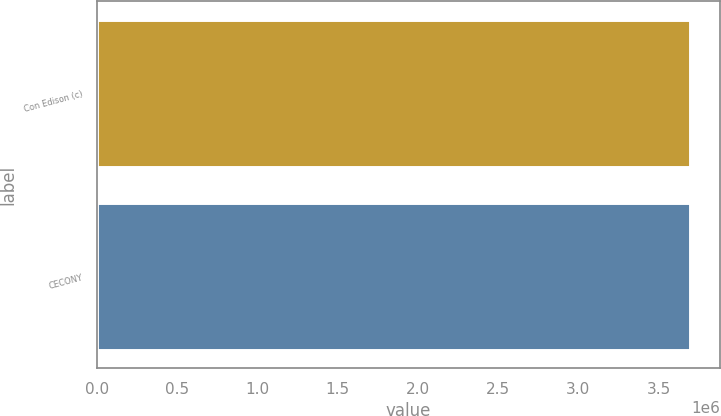Convert chart to OTSL. <chart><loc_0><loc_0><loc_500><loc_500><bar_chart><fcel>Con Edison (c)<fcel>CECONY<nl><fcel>3.696e+06<fcel>3.696e+06<nl></chart> 